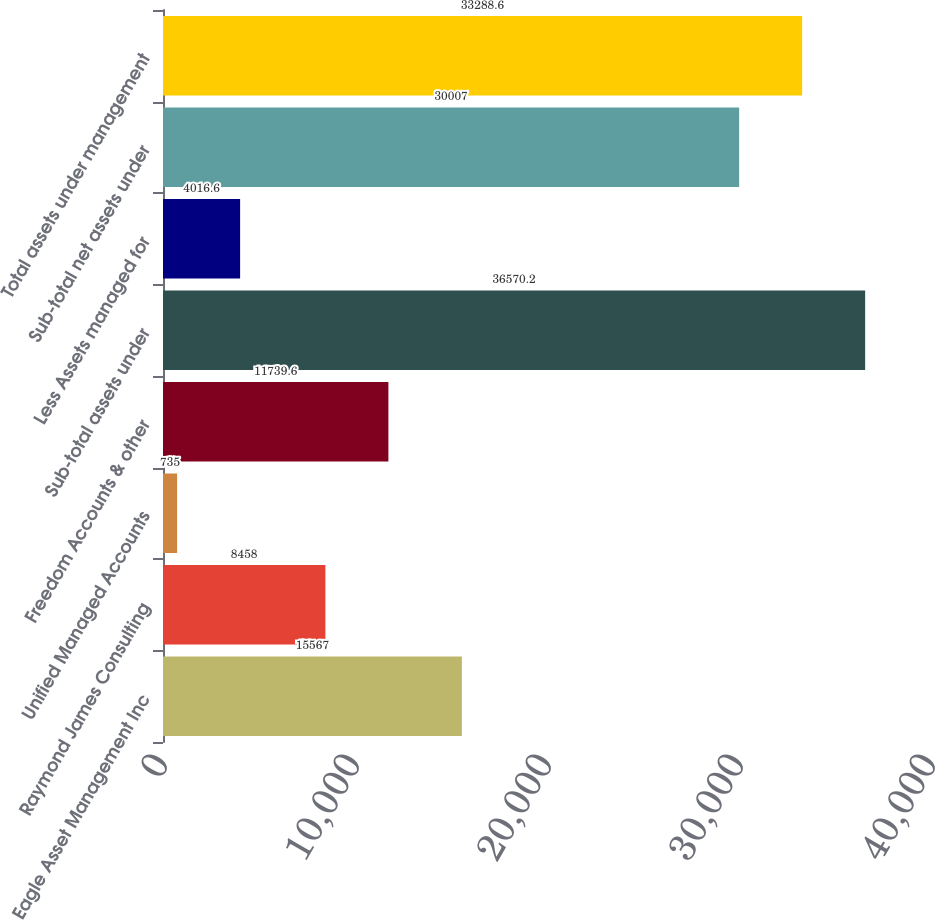Convert chart. <chart><loc_0><loc_0><loc_500><loc_500><bar_chart><fcel>Eagle Asset Management Inc<fcel>Raymond James Consulting<fcel>Unified Managed Accounts<fcel>Freedom Accounts & other<fcel>Sub-total assets under<fcel>Less Assets managed for<fcel>Sub-total net assets under<fcel>Total assets under management<nl><fcel>15567<fcel>8458<fcel>735<fcel>11739.6<fcel>36570.2<fcel>4016.6<fcel>30007<fcel>33288.6<nl></chart> 